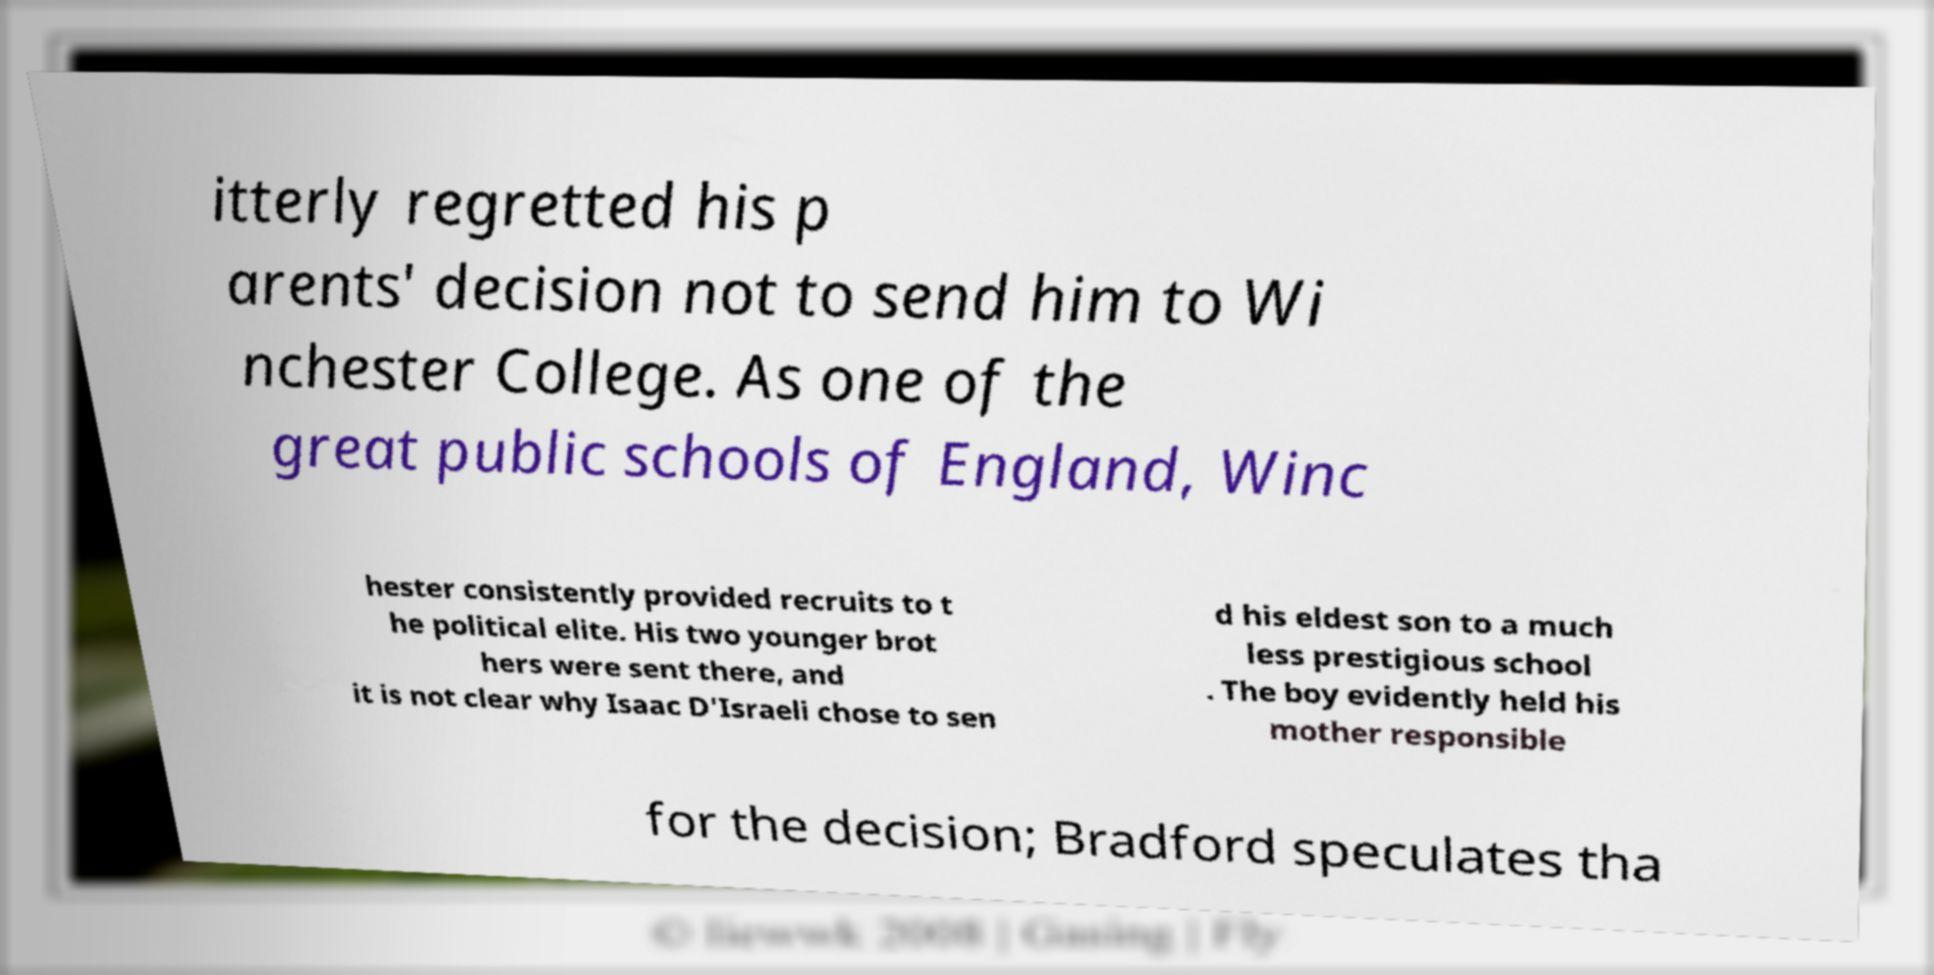Can you read and provide the text displayed in the image?This photo seems to have some interesting text. Can you extract and type it out for me? itterly regretted his p arents' decision not to send him to Wi nchester College. As one of the great public schools of England, Winc hester consistently provided recruits to t he political elite. His two younger brot hers were sent there, and it is not clear why Isaac D'Israeli chose to sen d his eldest son to a much less prestigious school . The boy evidently held his mother responsible for the decision; Bradford speculates tha 